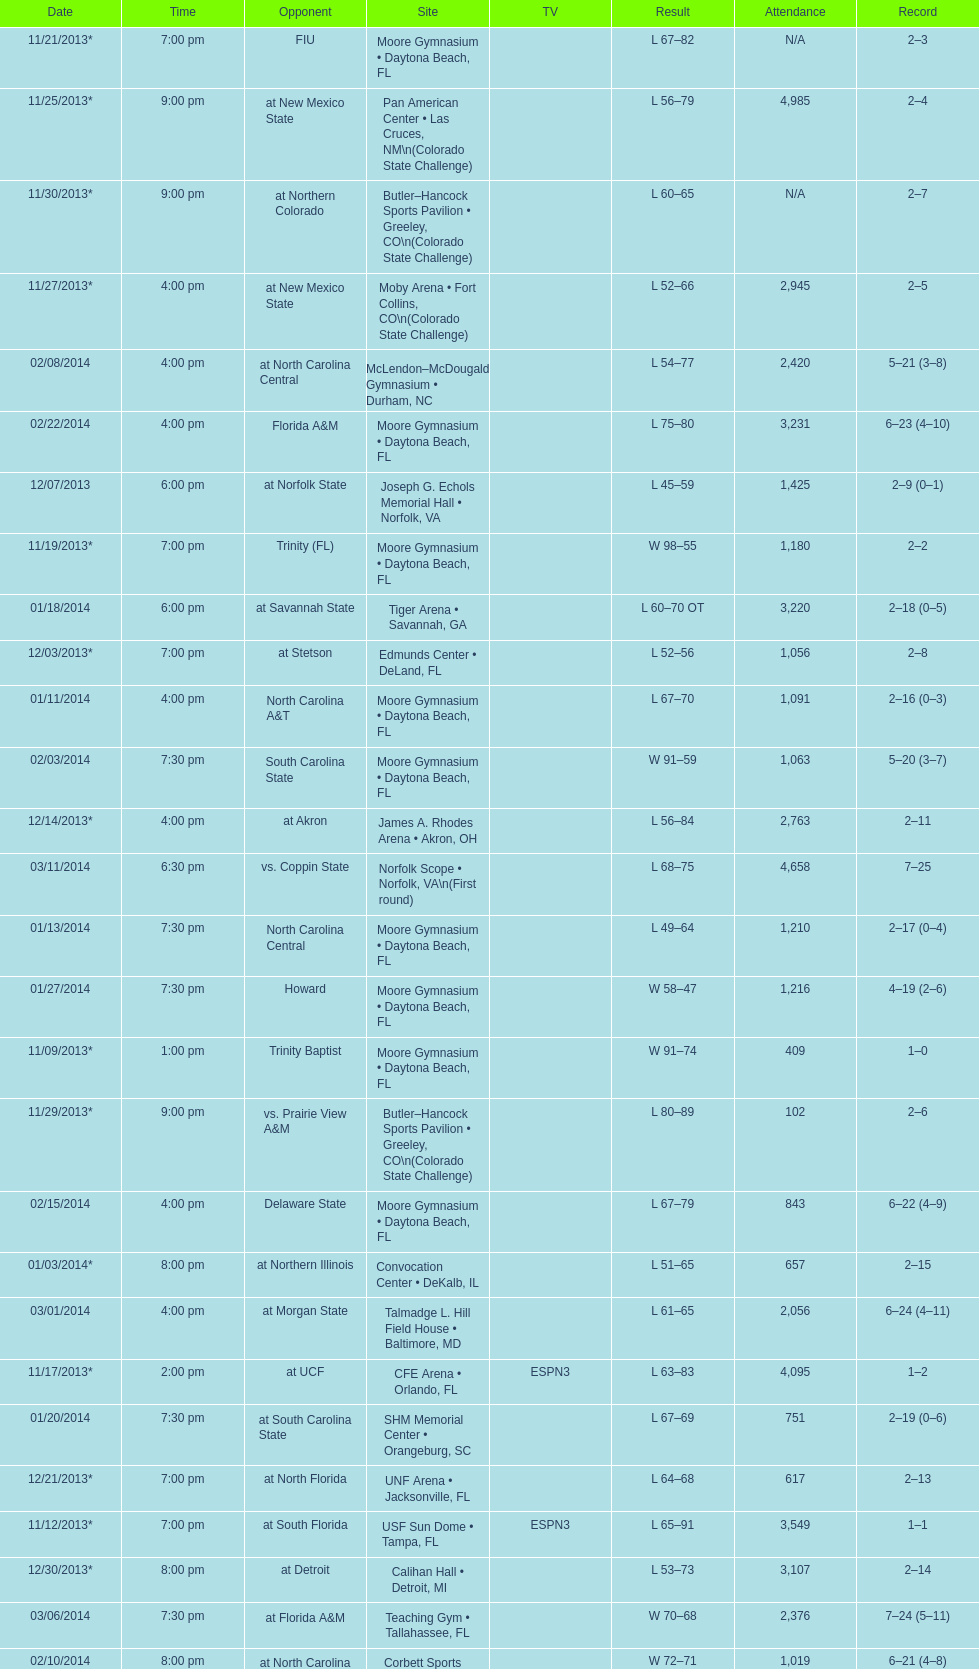Which game was won by a bigger margin, against trinity (fl) or against trinity baptist? Trinity (FL). 